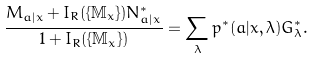Convert formula to latex. <formula><loc_0><loc_0><loc_500><loc_500>\frac { M _ { a | x } + I _ { R } ( \{ \mathbb { M } _ { x } \} ) N _ { a | x } ^ { * } } { 1 + I _ { R } ( \{ \mathbb { M } _ { x } \} ) } = \sum _ { \lambda } p ^ { * } ( a | x , \lambda ) G _ { \lambda } ^ { * } .</formula> 